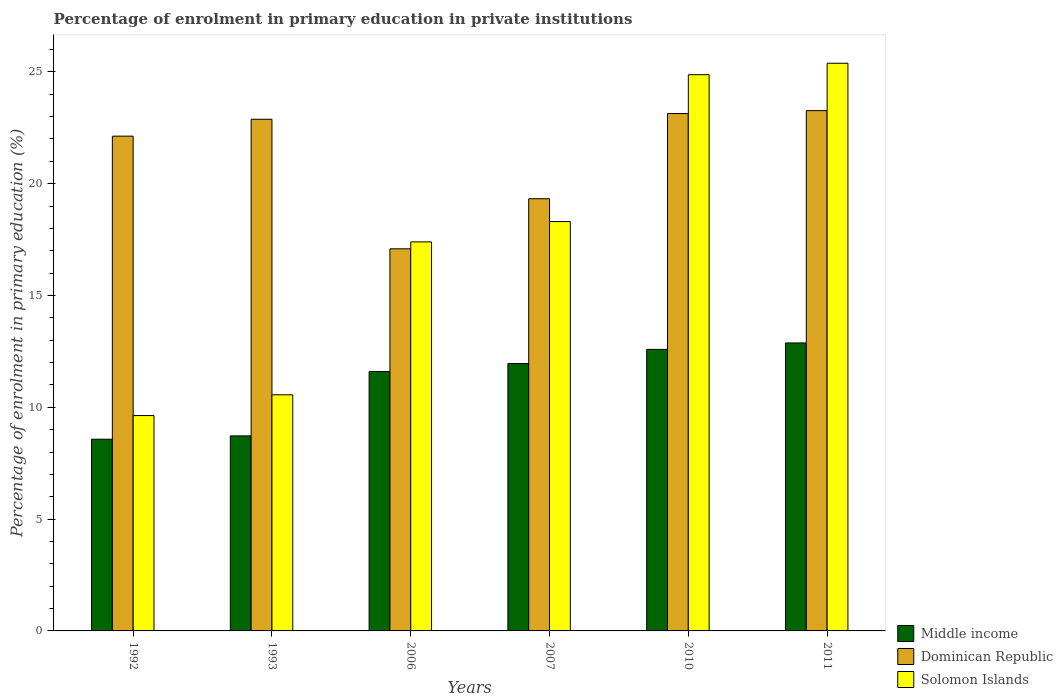Are the number of bars per tick equal to the number of legend labels?
Ensure brevity in your answer.  Yes. How many bars are there on the 4th tick from the left?
Your answer should be compact. 3. How many bars are there on the 6th tick from the right?
Make the answer very short. 3. In how many cases, is the number of bars for a given year not equal to the number of legend labels?
Your response must be concise. 0. What is the percentage of enrolment in primary education in Middle income in 2007?
Offer a terse response. 11.96. Across all years, what is the maximum percentage of enrolment in primary education in Solomon Islands?
Offer a very short reply. 25.38. Across all years, what is the minimum percentage of enrolment in primary education in Dominican Republic?
Provide a succinct answer. 17.09. In which year was the percentage of enrolment in primary education in Dominican Republic maximum?
Your answer should be very brief. 2011. What is the total percentage of enrolment in primary education in Dominican Republic in the graph?
Provide a short and direct response. 127.82. What is the difference between the percentage of enrolment in primary education in Dominican Republic in 1993 and that in 2007?
Make the answer very short. 3.55. What is the difference between the percentage of enrolment in primary education in Solomon Islands in 1992 and the percentage of enrolment in primary education in Dominican Republic in 2010?
Your response must be concise. -13.5. What is the average percentage of enrolment in primary education in Middle income per year?
Give a very brief answer. 11.05. In the year 2007, what is the difference between the percentage of enrolment in primary education in Solomon Islands and percentage of enrolment in primary education in Dominican Republic?
Offer a terse response. -1.02. In how many years, is the percentage of enrolment in primary education in Dominican Republic greater than 9 %?
Provide a short and direct response. 6. What is the ratio of the percentage of enrolment in primary education in Dominican Republic in 1992 to that in 2006?
Make the answer very short. 1.29. Is the difference between the percentage of enrolment in primary education in Solomon Islands in 2010 and 2011 greater than the difference between the percentage of enrolment in primary education in Dominican Republic in 2010 and 2011?
Provide a short and direct response. No. What is the difference between the highest and the second highest percentage of enrolment in primary education in Dominican Republic?
Provide a succinct answer. 0.13. What is the difference between the highest and the lowest percentage of enrolment in primary education in Dominican Republic?
Provide a succinct answer. 6.18. What does the 3rd bar from the left in 2006 represents?
Give a very brief answer. Solomon Islands. What does the 2nd bar from the right in 1992 represents?
Offer a terse response. Dominican Republic. Is it the case that in every year, the sum of the percentage of enrolment in primary education in Dominican Republic and percentage of enrolment in primary education in Solomon Islands is greater than the percentage of enrolment in primary education in Middle income?
Provide a succinct answer. Yes. How many years are there in the graph?
Your answer should be very brief. 6. Are the values on the major ticks of Y-axis written in scientific E-notation?
Keep it short and to the point. No. Does the graph contain any zero values?
Offer a very short reply. No. Where does the legend appear in the graph?
Provide a succinct answer. Bottom right. What is the title of the graph?
Offer a terse response. Percentage of enrolment in primary education in private institutions. Does "Slovenia" appear as one of the legend labels in the graph?
Offer a very short reply. No. What is the label or title of the Y-axis?
Provide a short and direct response. Percentage of enrolment in primary education (%). What is the Percentage of enrolment in primary education (%) in Middle income in 1992?
Provide a succinct answer. 8.57. What is the Percentage of enrolment in primary education (%) of Dominican Republic in 1992?
Ensure brevity in your answer.  22.12. What is the Percentage of enrolment in primary education (%) of Solomon Islands in 1992?
Your response must be concise. 9.63. What is the Percentage of enrolment in primary education (%) of Middle income in 1993?
Your response must be concise. 8.72. What is the Percentage of enrolment in primary education (%) of Dominican Republic in 1993?
Offer a terse response. 22.88. What is the Percentage of enrolment in primary education (%) of Solomon Islands in 1993?
Your response must be concise. 10.56. What is the Percentage of enrolment in primary education (%) in Middle income in 2006?
Give a very brief answer. 11.6. What is the Percentage of enrolment in primary education (%) of Dominican Republic in 2006?
Ensure brevity in your answer.  17.09. What is the Percentage of enrolment in primary education (%) of Solomon Islands in 2006?
Your response must be concise. 17.4. What is the Percentage of enrolment in primary education (%) of Middle income in 2007?
Provide a succinct answer. 11.96. What is the Percentage of enrolment in primary education (%) in Dominican Republic in 2007?
Your answer should be very brief. 19.33. What is the Percentage of enrolment in primary education (%) in Solomon Islands in 2007?
Give a very brief answer. 18.3. What is the Percentage of enrolment in primary education (%) in Middle income in 2010?
Your response must be concise. 12.59. What is the Percentage of enrolment in primary education (%) of Dominican Republic in 2010?
Your answer should be very brief. 23.13. What is the Percentage of enrolment in primary education (%) in Solomon Islands in 2010?
Ensure brevity in your answer.  24.87. What is the Percentage of enrolment in primary education (%) of Middle income in 2011?
Your answer should be very brief. 12.88. What is the Percentage of enrolment in primary education (%) in Dominican Republic in 2011?
Make the answer very short. 23.27. What is the Percentage of enrolment in primary education (%) of Solomon Islands in 2011?
Offer a very short reply. 25.38. Across all years, what is the maximum Percentage of enrolment in primary education (%) of Middle income?
Provide a succinct answer. 12.88. Across all years, what is the maximum Percentage of enrolment in primary education (%) in Dominican Republic?
Provide a succinct answer. 23.27. Across all years, what is the maximum Percentage of enrolment in primary education (%) in Solomon Islands?
Offer a terse response. 25.38. Across all years, what is the minimum Percentage of enrolment in primary education (%) of Middle income?
Provide a succinct answer. 8.57. Across all years, what is the minimum Percentage of enrolment in primary education (%) in Dominican Republic?
Keep it short and to the point. 17.09. Across all years, what is the minimum Percentage of enrolment in primary education (%) of Solomon Islands?
Ensure brevity in your answer.  9.63. What is the total Percentage of enrolment in primary education (%) of Middle income in the graph?
Your response must be concise. 66.31. What is the total Percentage of enrolment in primary education (%) of Dominican Republic in the graph?
Provide a succinct answer. 127.82. What is the total Percentage of enrolment in primary education (%) in Solomon Islands in the graph?
Keep it short and to the point. 106.14. What is the difference between the Percentage of enrolment in primary education (%) in Middle income in 1992 and that in 1993?
Give a very brief answer. -0.15. What is the difference between the Percentage of enrolment in primary education (%) of Dominican Republic in 1992 and that in 1993?
Provide a succinct answer. -0.76. What is the difference between the Percentage of enrolment in primary education (%) in Solomon Islands in 1992 and that in 1993?
Offer a terse response. -0.93. What is the difference between the Percentage of enrolment in primary education (%) of Middle income in 1992 and that in 2006?
Give a very brief answer. -3.03. What is the difference between the Percentage of enrolment in primary education (%) in Dominican Republic in 1992 and that in 2006?
Your answer should be very brief. 5.04. What is the difference between the Percentage of enrolment in primary education (%) in Solomon Islands in 1992 and that in 2006?
Provide a short and direct response. -7.76. What is the difference between the Percentage of enrolment in primary education (%) of Middle income in 1992 and that in 2007?
Give a very brief answer. -3.38. What is the difference between the Percentage of enrolment in primary education (%) of Dominican Republic in 1992 and that in 2007?
Give a very brief answer. 2.8. What is the difference between the Percentage of enrolment in primary education (%) in Solomon Islands in 1992 and that in 2007?
Offer a terse response. -8.67. What is the difference between the Percentage of enrolment in primary education (%) of Middle income in 1992 and that in 2010?
Your response must be concise. -4.02. What is the difference between the Percentage of enrolment in primary education (%) of Dominican Republic in 1992 and that in 2010?
Make the answer very short. -1.01. What is the difference between the Percentage of enrolment in primary education (%) of Solomon Islands in 1992 and that in 2010?
Offer a terse response. -15.24. What is the difference between the Percentage of enrolment in primary education (%) of Middle income in 1992 and that in 2011?
Give a very brief answer. -4.3. What is the difference between the Percentage of enrolment in primary education (%) of Dominican Republic in 1992 and that in 2011?
Offer a very short reply. -1.14. What is the difference between the Percentage of enrolment in primary education (%) of Solomon Islands in 1992 and that in 2011?
Your answer should be very brief. -15.75. What is the difference between the Percentage of enrolment in primary education (%) in Middle income in 1993 and that in 2006?
Make the answer very short. -2.88. What is the difference between the Percentage of enrolment in primary education (%) in Dominican Republic in 1993 and that in 2006?
Offer a terse response. 5.79. What is the difference between the Percentage of enrolment in primary education (%) of Solomon Islands in 1993 and that in 2006?
Keep it short and to the point. -6.84. What is the difference between the Percentage of enrolment in primary education (%) of Middle income in 1993 and that in 2007?
Make the answer very short. -3.23. What is the difference between the Percentage of enrolment in primary education (%) of Dominican Republic in 1993 and that in 2007?
Ensure brevity in your answer.  3.55. What is the difference between the Percentage of enrolment in primary education (%) in Solomon Islands in 1993 and that in 2007?
Your answer should be very brief. -7.75. What is the difference between the Percentage of enrolment in primary education (%) in Middle income in 1993 and that in 2010?
Offer a terse response. -3.87. What is the difference between the Percentage of enrolment in primary education (%) in Dominican Republic in 1993 and that in 2010?
Your response must be concise. -0.26. What is the difference between the Percentage of enrolment in primary education (%) of Solomon Islands in 1993 and that in 2010?
Ensure brevity in your answer.  -14.31. What is the difference between the Percentage of enrolment in primary education (%) of Middle income in 1993 and that in 2011?
Provide a succinct answer. -4.16. What is the difference between the Percentage of enrolment in primary education (%) of Dominican Republic in 1993 and that in 2011?
Offer a very short reply. -0.39. What is the difference between the Percentage of enrolment in primary education (%) of Solomon Islands in 1993 and that in 2011?
Give a very brief answer. -14.83. What is the difference between the Percentage of enrolment in primary education (%) of Middle income in 2006 and that in 2007?
Offer a terse response. -0.36. What is the difference between the Percentage of enrolment in primary education (%) in Dominican Republic in 2006 and that in 2007?
Provide a short and direct response. -2.24. What is the difference between the Percentage of enrolment in primary education (%) of Solomon Islands in 2006 and that in 2007?
Give a very brief answer. -0.91. What is the difference between the Percentage of enrolment in primary education (%) of Middle income in 2006 and that in 2010?
Your response must be concise. -0.99. What is the difference between the Percentage of enrolment in primary education (%) of Dominican Republic in 2006 and that in 2010?
Offer a terse response. -6.05. What is the difference between the Percentage of enrolment in primary education (%) in Solomon Islands in 2006 and that in 2010?
Offer a very short reply. -7.48. What is the difference between the Percentage of enrolment in primary education (%) in Middle income in 2006 and that in 2011?
Provide a short and direct response. -1.28. What is the difference between the Percentage of enrolment in primary education (%) of Dominican Republic in 2006 and that in 2011?
Your answer should be compact. -6.18. What is the difference between the Percentage of enrolment in primary education (%) of Solomon Islands in 2006 and that in 2011?
Your answer should be very brief. -7.99. What is the difference between the Percentage of enrolment in primary education (%) in Middle income in 2007 and that in 2010?
Offer a terse response. -0.63. What is the difference between the Percentage of enrolment in primary education (%) of Dominican Republic in 2007 and that in 2010?
Your answer should be very brief. -3.81. What is the difference between the Percentage of enrolment in primary education (%) of Solomon Islands in 2007 and that in 2010?
Provide a short and direct response. -6.57. What is the difference between the Percentage of enrolment in primary education (%) in Middle income in 2007 and that in 2011?
Offer a terse response. -0.92. What is the difference between the Percentage of enrolment in primary education (%) of Dominican Republic in 2007 and that in 2011?
Ensure brevity in your answer.  -3.94. What is the difference between the Percentage of enrolment in primary education (%) of Solomon Islands in 2007 and that in 2011?
Offer a terse response. -7.08. What is the difference between the Percentage of enrolment in primary education (%) in Middle income in 2010 and that in 2011?
Provide a short and direct response. -0.29. What is the difference between the Percentage of enrolment in primary education (%) in Dominican Republic in 2010 and that in 2011?
Offer a very short reply. -0.13. What is the difference between the Percentage of enrolment in primary education (%) in Solomon Islands in 2010 and that in 2011?
Your answer should be compact. -0.51. What is the difference between the Percentage of enrolment in primary education (%) of Middle income in 1992 and the Percentage of enrolment in primary education (%) of Dominican Republic in 1993?
Offer a very short reply. -14.31. What is the difference between the Percentage of enrolment in primary education (%) in Middle income in 1992 and the Percentage of enrolment in primary education (%) in Solomon Islands in 1993?
Your response must be concise. -1.99. What is the difference between the Percentage of enrolment in primary education (%) of Dominican Republic in 1992 and the Percentage of enrolment in primary education (%) of Solomon Islands in 1993?
Give a very brief answer. 11.57. What is the difference between the Percentage of enrolment in primary education (%) in Middle income in 1992 and the Percentage of enrolment in primary education (%) in Dominican Republic in 2006?
Your response must be concise. -8.51. What is the difference between the Percentage of enrolment in primary education (%) in Middle income in 1992 and the Percentage of enrolment in primary education (%) in Solomon Islands in 2006?
Offer a terse response. -8.82. What is the difference between the Percentage of enrolment in primary education (%) in Dominican Republic in 1992 and the Percentage of enrolment in primary education (%) in Solomon Islands in 2006?
Ensure brevity in your answer.  4.73. What is the difference between the Percentage of enrolment in primary education (%) of Middle income in 1992 and the Percentage of enrolment in primary education (%) of Dominican Republic in 2007?
Your answer should be compact. -10.75. What is the difference between the Percentage of enrolment in primary education (%) in Middle income in 1992 and the Percentage of enrolment in primary education (%) in Solomon Islands in 2007?
Make the answer very short. -9.73. What is the difference between the Percentage of enrolment in primary education (%) in Dominican Republic in 1992 and the Percentage of enrolment in primary education (%) in Solomon Islands in 2007?
Make the answer very short. 3.82. What is the difference between the Percentage of enrolment in primary education (%) in Middle income in 1992 and the Percentage of enrolment in primary education (%) in Dominican Republic in 2010?
Make the answer very short. -14.56. What is the difference between the Percentage of enrolment in primary education (%) in Middle income in 1992 and the Percentage of enrolment in primary education (%) in Solomon Islands in 2010?
Make the answer very short. -16.3. What is the difference between the Percentage of enrolment in primary education (%) of Dominican Republic in 1992 and the Percentage of enrolment in primary education (%) of Solomon Islands in 2010?
Provide a short and direct response. -2.75. What is the difference between the Percentage of enrolment in primary education (%) in Middle income in 1992 and the Percentage of enrolment in primary education (%) in Dominican Republic in 2011?
Offer a very short reply. -14.69. What is the difference between the Percentage of enrolment in primary education (%) in Middle income in 1992 and the Percentage of enrolment in primary education (%) in Solomon Islands in 2011?
Offer a very short reply. -16.81. What is the difference between the Percentage of enrolment in primary education (%) of Dominican Republic in 1992 and the Percentage of enrolment in primary education (%) of Solomon Islands in 2011?
Ensure brevity in your answer.  -3.26. What is the difference between the Percentage of enrolment in primary education (%) of Middle income in 1993 and the Percentage of enrolment in primary education (%) of Dominican Republic in 2006?
Provide a short and direct response. -8.37. What is the difference between the Percentage of enrolment in primary education (%) in Middle income in 1993 and the Percentage of enrolment in primary education (%) in Solomon Islands in 2006?
Provide a short and direct response. -8.67. What is the difference between the Percentage of enrolment in primary education (%) in Dominican Republic in 1993 and the Percentage of enrolment in primary education (%) in Solomon Islands in 2006?
Give a very brief answer. 5.48. What is the difference between the Percentage of enrolment in primary education (%) in Middle income in 1993 and the Percentage of enrolment in primary education (%) in Dominican Republic in 2007?
Ensure brevity in your answer.  -10.61. What is the difference between the Percentage of enrolment in primary education (%) of Middle income in 1993 and the Percentage of enrolment in primary education (%) of Solomon Islands in 2007?
Provide a succinct answer. -9.58. What is the difference between the Percentage of enrolment in primary education (%) of Dominican Republic in 1993 and the Percentage of enrolment in primary education (%) of Solomon Islands in 2007?
Provide a short and direct response. 4.58. What is the difference between the Percentage of enrolment in primary education (%) in Middle income in 1993 and the Percentage of enrolment in primary education (%) in Dominican Republic in 2010?
Your answer should be very brief. -14.41. What is the difference between the Percentage of enrolment in primary education (%) of Middle income in 1993 and the Percentage of enrolment in primary education (%) of Solomon Islands in 2010?
Offer a very short reply. -16.15. What is the difference between the Percentage of enrolment in primary education (%) in Dominican Republic in 1993 and the Percentage of enrolment in primary education (%) in Solomon Islands in 2010?
Offer a terse response. -1.99. What is the difference between the Percentage of enrolment in primary education (%) of Middle income in 1993 and the Percentage of enrolment in primary education (%) of Dominican Republic in 2011?
Offer a terse response. -14.54. What is the difference between the Percentage of enrolment in primary education (%) of Middle income in 1993 and the Percentage of enrolment in primary education (%) of Solomon Islands in 2011?
Give a very brief answer. -16.66. What is the difference between the Percentage of enrolment in primary education (%) in Dominican Republic in 1993 and the Percentage of enrolment in primary education (%) in Solomon Islands in 2011?
Make the answer very short. -2.5. What is the difference between the Percentage of enrolment in primary education (%) of Middle income in 2006 and the Percentage of enrolment in primary education (%) of Dominican Republic in 2007?
Provide a short and direct response. -7.73. What is the difference between the Percentage of enrolment in primary education (%) of Middle income in 2006 and the Percentage of enrolment in primary education (%) of Solomon Islands in 2007?
Your answer should be very brief. -6.71. What is the difference between the Percentage of enrolment in primary education (%) of Dominican Republic in 2006 and the Percentage of enrolment in primary education (%) of Solomon Islands in 2007?
Provide a short and direct response. -1.22. What is the difference between the Percentage of enrolment in primary education (%) in Middle income in 2006 and the Percentage of enrolment in primary education (%) in Dominican Republic in 2010?
Keep it short and to the point. -11.54. What is the difference between the Percentage of enrolment in primary education (%) of Middle income in 2006 and the Percentage of enrolment in primary education (%) of Solomon Islands in 2010?
Offer a very short reply. -13.27. What is the difference between the Percentage of enrolment in primary education (%) of Dominican Republic in 2006 and the Percentage of enrolment in primary education (%) of Solomon Islands in 2010?
Your response must be concise. -7.79. What is the difference between the Percentage of enrolment in primary education (%) of Middle income in 2006 and the Percentage of enrolment in primary education (%) of Dominican Republic in 2011?
Give a very brief answer. -11.67. What is the difference between the Percentage of enrolment in primary education (%) of Middle income in 2006 and the Percentage of enrolment in primary education (%) of Solomon Islands in 2011?
Give a very brief answer. -13.79. What is the difference between the Percentage of enrolment in primary education (%) in Dominican Republic in 2006 and the Percentage of enrolment in primary education (%) in Solomon Islands in 2011?
Ensure brevity in your answer.  -8.3. What is the difference between the Percentage of enrolment in primary education (%) in Middle income in 2007 and the Percentage of enrolment in primary education (%) in Dominican Republic in 2010?
Offer a very short reply. -11.18. What is the difference between the Percentage of enrolment in primary education (%) in Middle income in 2007 and the Percentage of enrolment in primary education (%) in Solomon Islands in 2010?
Your response must be concise. -12.92. What is the difference between the Percentage of enrolment in primary education (%) of Dominican Republic in 2007 and the Percentage of enrolment in primary education (%) of Solomon Islands in 2010?
Give a very brief answer. -5.55. What is the difference between the Percentage of enrolment in primary education (%) in Middle income in 2007 and the Percentage of enrolment in primary education (%) in Dominican Republic in 2011?
Make the answer very short. -11.31. What is the difference between the Percentage of enrolment in primary education (%) of Middle income in 2007 and the Percentage of enrolment in primary education (%) of Solomon Islands in 2011?
Give a very brief answer. -13.43. What is the difference between the Percentage of enrolment in primary education (%) of Dominican Republic in 2007 and the Percentage of enrolment in primary education (%) of Solomon Islands in 2011?
Give a very brief answer. -6.06. What is the difference between the Percentage of enrolment in primary education (%) in Middle income in 2010 and the Percentage of enrolment in primary education (%) in Dominican Republic in 2011?
Give a very brief answer. -10.68. What is the difference between the Percentage of enrolment in primary education (%) of Middle income in 2010 and the Percentage of enrolment in primary education (%) of Solomon Islands in 2011?
Offer a terse response. -12.79. What is the difference between the Percentage of enrolment in primary education (%) of Dominican Republic in 2010 and the Percentage of enrolment in primary education (%) of Solomon Islands in 2011?
Ensure brevity in your answer.  -2.25. What is the average Percentage of enrolment in primary education (%) in Middle income per year?
Your answer should be very brief. 11.05. What is the average Percentage of enrolment in primary education (%) of Dominican Republic per year?
Provide a short and direct response. 21.3. What is the average Percentage of enrolment in primary education (%) in Solomon Islands per year?
Your response must be concise. 17.69. In the year 1992, what is the difference between the Percentage of enrolment in primary education (%) in Middle income and Percentage of enrolment in primary education (%) in Dominican Republic?
Provide a succinct answer. -13.55. In the year 1992, what is the difference between the Percentage of enrolment in primary education (%) of Middle income and Percentage of enrolment in primary education (%) of Solomon Islands?
Your response must be concise. -1.06. In the year 1992, what is the difference between the Percentage of enrolment in primary education (%) of Dominican Republic and Percentage of enrolment in primary education (%) of Solomon Islands?
Keep it short and to the point. 12.49. In the year 1993, what is the difference between the Percentage of enrolment in primary education (%) in Middle income and Percentage of enrolment in primary education (%) in Dominican Republic?
Give a very brief answer. -14.16. In the year 1993, what is the difference between the Percentage of enrolment in primary education (%) in Middle income and Percentage of enrolment in primary education (%) in Solomon Islands?
Your answer should be compact. -1.84. In the year 1993, what is the difference between the Percentage of enrolment in primary education (%) of Dominican Republic and Percentage of enrolment in primary education (%) of Solomon Islands?
Offer a very short reply. 12.32. In the year 2006, what is the difference between the Percentage of enrolment in primary education (%) in Middle income and Percentage of enrolment in primary education (%) in Dominican Republic?
Your response must be concise. -5.49. In the year 2006, what is the difference between the Percentage of enrolment in primary education (%) in Middle income and Percentage of enrolment in primary education (%) in Solomon Islands?
Your answer should be very brief. -5.8. In the year 2006, what is the difference between the Percentage of enrolment in primary education (%) of Dominican Republic and Percentage of enrolment in primary education (%) of Solomon Islands?
Keep it short and to the point. -0.31. In the year 2007, what is the difference between the Percentage of enrolment in primary education (%) in Middle income and Percentage of enrolment in primary education (%) in Dominican Republic?
Your answer should be compact. -7.37. In the year 2007, what is the difference between the Percentage of enrolment in primary education (%) of Middle income and Percentage of enrolment in primary education (%) of Solomon Islands?
Make the answer very short. -6.35. In the year 2007, what is the difference between the Percentage of enrolment in primary education (%) in Dominican Republic and Percentage of enrolment in primary education (%) in Solomon Islands?
Offer a terse response. 1.02. In the year 2010, what is the difference between the Percentage of enrolment in primary education (%) of Middle income and Percentage of enrolment in primary education (%) of Dominican Republic?
Give a very brief answer. -10.55. In the year 2010, what is the difference between the Percentage of enrolment in primary education (%) of Middle income and Percentage of enrolment in primary education (%) of Solomon Islands?
Make the answer very short. -12.28. In the year 2010, what is the difference between the Percentage of enrolment in primary education (%) of Dominican Republic and Percentage of enrolment in primary education (%) of Solomon Islands?
Keep it short and to the point. -1.74. In the year 2011, what is the difference between the Percentage of enrolment in primary education (%) of Middle income and Percentage of enrolment in primary education (%) of Dominican Republic?
Keep it short and to the point. -10.39. In the year 2011, what is the difference between the Percentage of enrolment in primary education (%) of Middle income and Percentage of enrolment in primary education (%) of Solomon Islands?
Ensure brevity in your answer.  -12.51. In the year 2011, what is the difference between the Percentage of enrolment in primary education (%) in Dominican Republic and Percentage of enrolment in primary education (%) in Solomon Islands?
Provide a short and direct response. -2.12. What is the ratio of the Percentage of enrolment in primary education (%) of Middle income in 1992 to that in 1993?
Provide a short and direct response. 0.98. What is the ratio of the Percentage of enrolment in primary education (%) of Solomon Islands in 1992 to that in 1993?
Give a very brief answer. 0.91. What is the ratio of the Percentage of enrolment in primary education (%) of Middle income in 1992 to that in 2006?
Keep it short and to the point. 0.74. What is the ratio of the Percentage of enrolment in primary education (%) of Dominican Republic in 1992 to that in 2006?
Offer a very short reply. 1.29. What is the ratio of the Percentage of enrolment in primary education (%) in Solomon Islands in 1992 to that in 2006?
Make the answer very short. 0.55. What is the ratio of the Percentage of enrolment in primary education (%) in Middle income in 1992 to that in 2007?
Your answer should be compact. 0.72. What is the ratio of the Percentage of enrolment in primary education (%) in Dominican Republic in 1992 to that in 2007?
Provide a succinct answer. 1.14. What is the ratio of the Percentage of enrolment in primary education (%) in Solomon Islands in 1992 to that in 2007?
Ensure brevity in your answer.  0.53. What is the ratio of the Percentage of enrolment in primary education (%) of Middle income in 1992 to that in 2010?
Offer a terse response. 0.68. What is the ratio of the Percentage of enrolment in primary education (%) of Dominican Republic in 1992 to that in 2010?
Your response must be concise. 0.96. What is the ratio of the Percentage of enrolment in primary education (%) of Solomon Islands in 1992 to that in 2010?
Ensure brevity in your answer.  0.39. What is the ratio of the Percentage of enrolment in primary education (%) in Middle income in 1992 to that in 2011?
Ensure brevity in your answer.  0.67. What is the ratio of the Percentage of enrolment in primary education (%) of Dominican Republic in 1992 to that in 2011?
Offer a terse response. 0.95. What is the ratio of the Percentage of enrolment in primary education (%) of Solomon Islands in 1992 to that in 2011?
Make the answer very short. 0.38. What is the ratio of the Percentage of enrolment in primary education (%) of Middle income in 1993 to that in 2006?
Offer a very short reply. 0.75. What is the ratio of the Percentage of enrolment in primary education (%) of Dominican Republic in 1993 to that in 2006?
Ensure brevity in your answer.  1.34. What is the ratio of the Percentage of enrolment in primary education (%) in Solomon Islands in 1993 to that in 2006?
Your response must be concise. 0.61. What is the ratio of the Percentage of enrolment in primary education (%) of Middle income in 1993 to that in 2007?
Provide a short and direct response. 0.73. What is the ratio of the Percentage of enrolment in primary education (%) of Dominican Republic in 1993 to that in 2007?
Provide a short and direct response. 1.18. What is the ratio of the Percentage of enrolment in primary education (%) in Solomon Islands in 1993 to that in 2007?
Your response must be concise. 0.58. What is the ratio of the Percentage of enrolment in primary education (%) of Middle income in 1993 to that in 2010?
Give a very brief answer. 0.69. What is the ratio of the Percentage of enrolment in primary education (%) of Solomon Islands in 1993 to that in 2010?
Offer a very short reply. 0.42. What is the ratio of the Percentage of enrolment in primary education (%) in Middle income in 1993 to that in 2011?
Keep it short and to the point. 0.68. What is the ratio of the Percentage of enrolment in primary education (%) in Dominican Republic in 1993 to that in 2011?
Your answer should be compact. 0.98. What is the ratio of the Percentage of enrolment in primary education (%) of Solomon Islands in 1993 to that in 2011?
Provide a succinct answer. 0.42. What is the ratio of the Percentage of enrolment in primary education (%) in Middle income in 2006 to that in 2007?
Your answer should be very brief. 0.97. What is the ratio of the Percentage of enrolment in primary education (%) in Dominican Republic in 2006 to that in 2007?
Provide a short and direct response. 0.88. What is the ratio of the Percentage of enrolment in primary education (%) of Solomon Islands in 2006 to that in 2007?
Keep it short and to the point. 0.95. What is the ratio of the Percentage of enrolment in primary education (%) of Middle income in 2006 to that in 2010?
Your answer should be very brief. 0.92. What is the ratio of the Percentage of enrolment in primary education (%) of Dominican Republic in 2006 to that in 2010?
Ensure brevity in your answer.  0.74. What is the ratio of the Percentage of enrolment in primary education (%) in Solomon Islands in 2006 to that in 2010?
Make the answer very short. 0.7. What is the ratio of the Percentage of enrolment in primary education (%) of Middle income in 2006 to that in 2011?
Keep it short and to the point. 0.9. What is the ratio of the Percentage of enrolment in primary education (%) of Dominican Republic in 2006 to that in 2011?
Offer a terse response. 0.73. What is the ratio of the Percentage of enrolment in primary education (%) of Solomon Islands in 2006 to that in 2011?
Offer a terse response. 0.69. What is the ratio of the Percentage of enrolment in primary education (%) in Middle income in 2007 to that in 2010?
Your response must be concise. 0.95. What is the ratio of the Percentage of enrolment in primary education (%) of Dominican Republic in 2007 to that in 2010?
Make the answer very short. 0.84. What is the ratio of the Percentage of enrolment in primary education (%) of Solomon Islands in 2007 to that in 2010?
Give a very brief answer. 0.74. What is the ratio of the Percentage of enrolment in primary education (%) in Middle income in 2007 to that in 2011?
Provide a succinct answer. 0.93. What is the ratio of the Percentage of enrolment in primary education (%) of Dominican Republic in 2007 to that in 2011?
Make the answer very short. 0.83. What is the ratio of the Percentage of enrolment in primary education (%) in Solomon Islands in 2007 to that in 2011?
Your answer should be compact. 0.72. What is the ratio of the Percentage of enrolment in primary education (%) of Middle income in 2010 to that in 2011?
Your answer should be very brief. 0.98. What is the ratio of the Percentage of enrolment in primary education (%) of Dominican Republic in 2010 to that in 2011?
Your answer should be very brief. 0.99. What is the ratio of the Percentage of enrolment in primary education (%) of Solomon Islands in 2010 to that in 2011?
Offer a terse response. 0.98. What is the difference between the highest and the second highest Percentage of enrolment in primary education (%) of Middle income?
Give a very brief answer. 0.29. What is the difference between the highest and the second highest Percentage of enrolment in primary education (%) of Dominican Republic?
Your answer should be compact. 0.13. What is the difference between the highest and the second highest Percentage of enrolment in primary education (%) in Solomon Islands?
Ensure brevity in your answer.  0.51. What is the difference between the highest and the lowest Percentage of enrolment in primary education (%) in Middle income?
Provide a succinct answer. 4.3. What is the difference between the highest and the lowest Percentage of enrolment in primary education (%) in Dominican Republic?
Provide a succinct answer. 6.18. What is the difference between the highest and the lowest Percentage of enrolment in primary education (%) of Solomon Islands?
Provide a short and direct response. 15.75. 